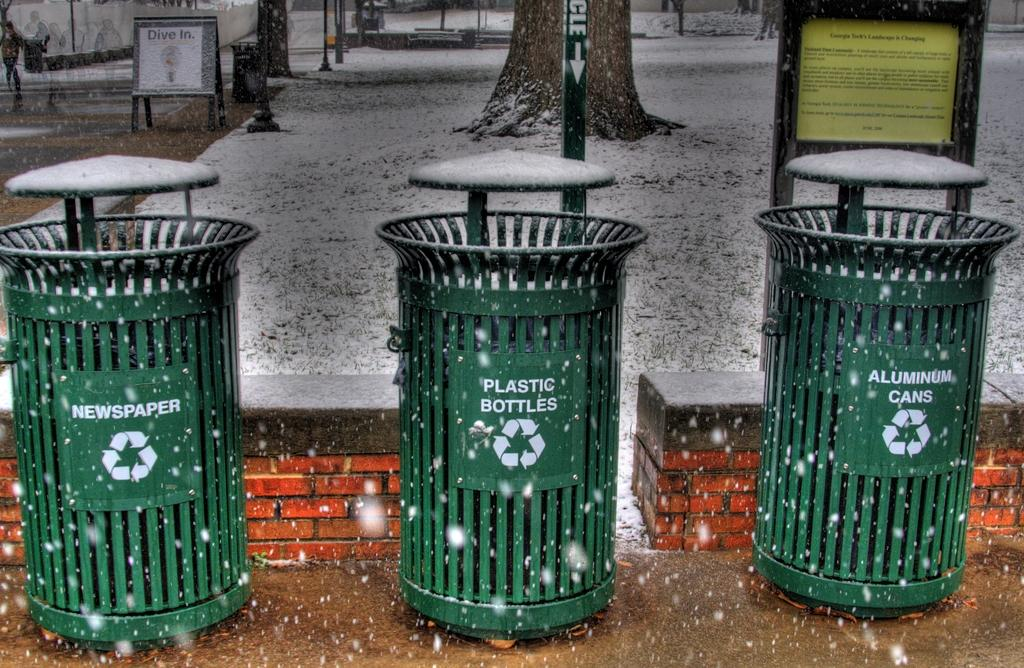<image>
Share a concise interpretation of the image provided. Three trash receptacles have labels including newspaper, plastic bottles, and aluminum cans. 